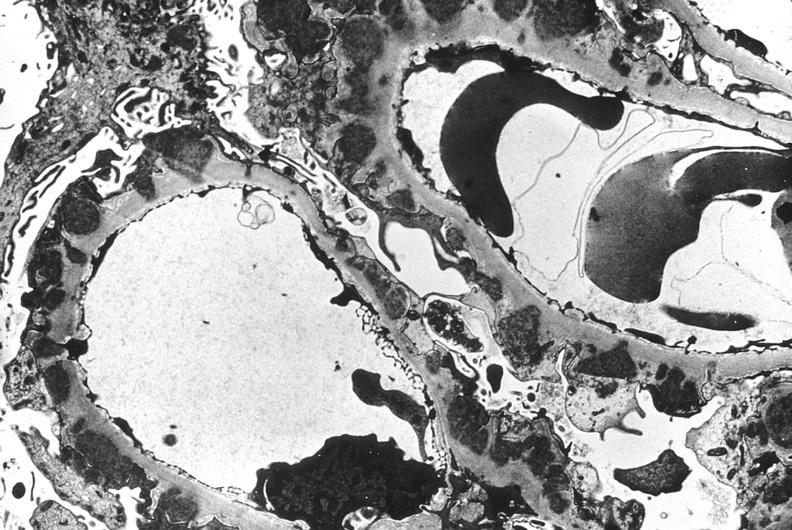where is this?
Answer the question using a single word or phrase. Urinary 